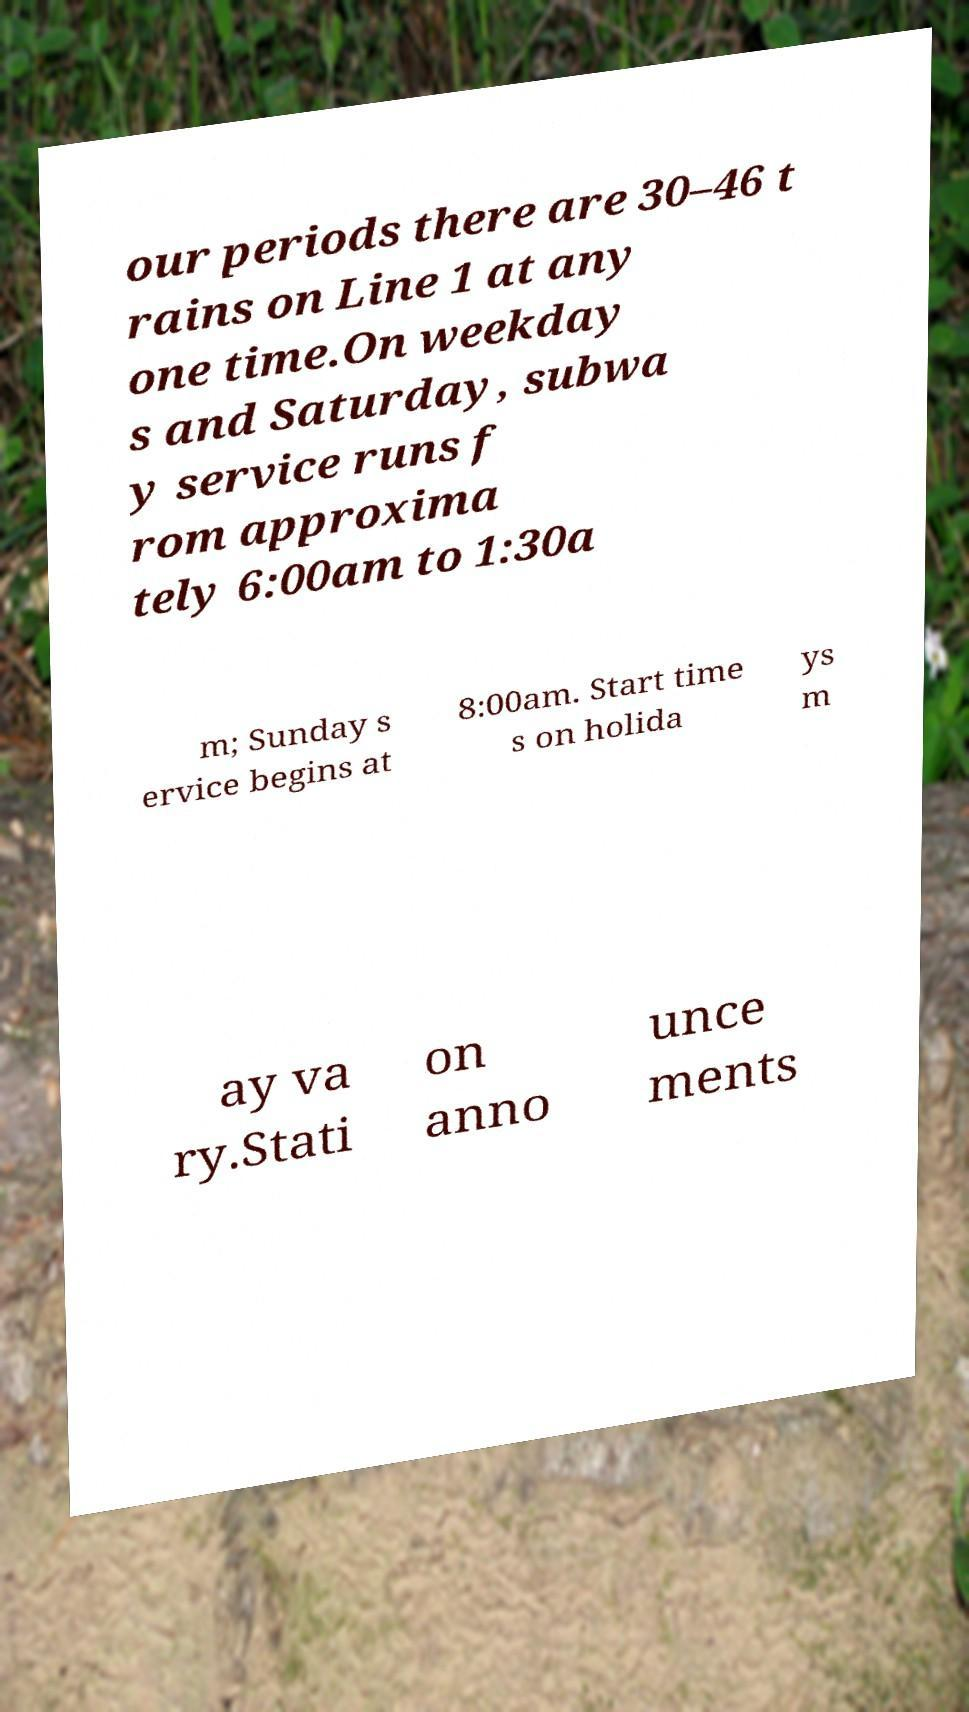Can you read and provide the text displayed in the image?This photo seems to have some interesting text. Can you extract and type it out for me? our periods there are 30–46 t rains on Line 1 at any one time.On weekday s and Saturday, subwa y service runs f rom approxima tely 6:00am to 1:30a m; Sunday s ervice begins at 8:00am. Start time s on holida ys m ay va ry.Stati on anno unce ments 